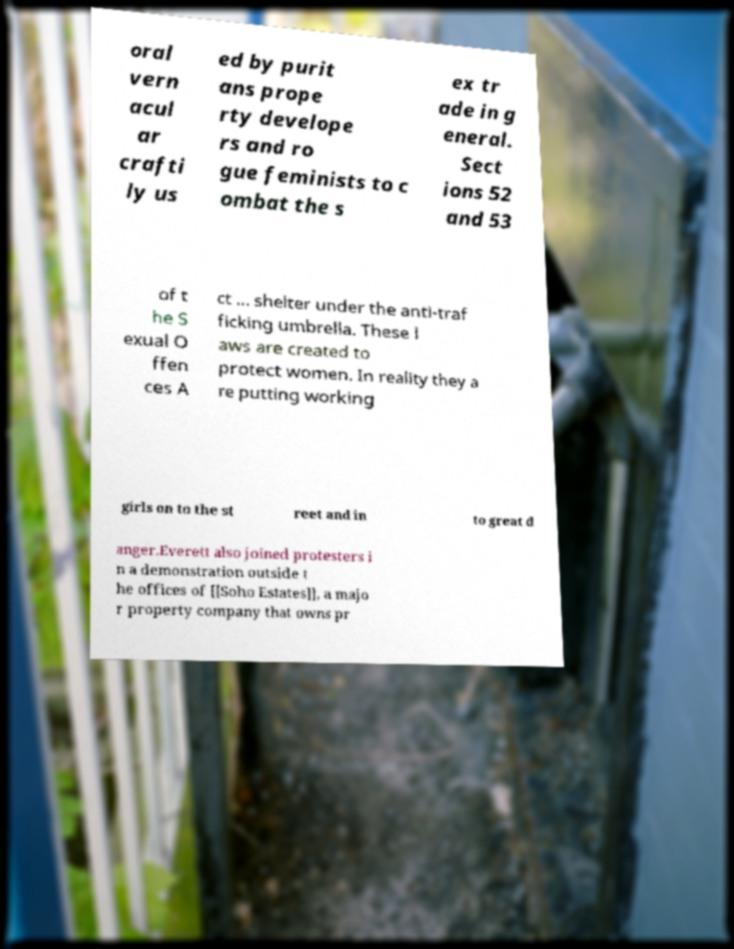For documentation purposes, I need the text within this image transcribed. Could you provide that? oral vern acul ar crafti ly us ed by purit ans prope rty develope rs and ro gue feminists to c ombat the s ex tr ade in g eneral. Sect ions 52 and 53 of t he S exual O ffen ces A ct ... shelter under the anti-traf ficking umbrella. These l aws are created to protect women. In reality they a re putting working girls on to the st reet and in to great d anger.Everett also joined protesters i n a demonstration outside t he offices of [[Soho Estates]], a majo r property company that owns pr 